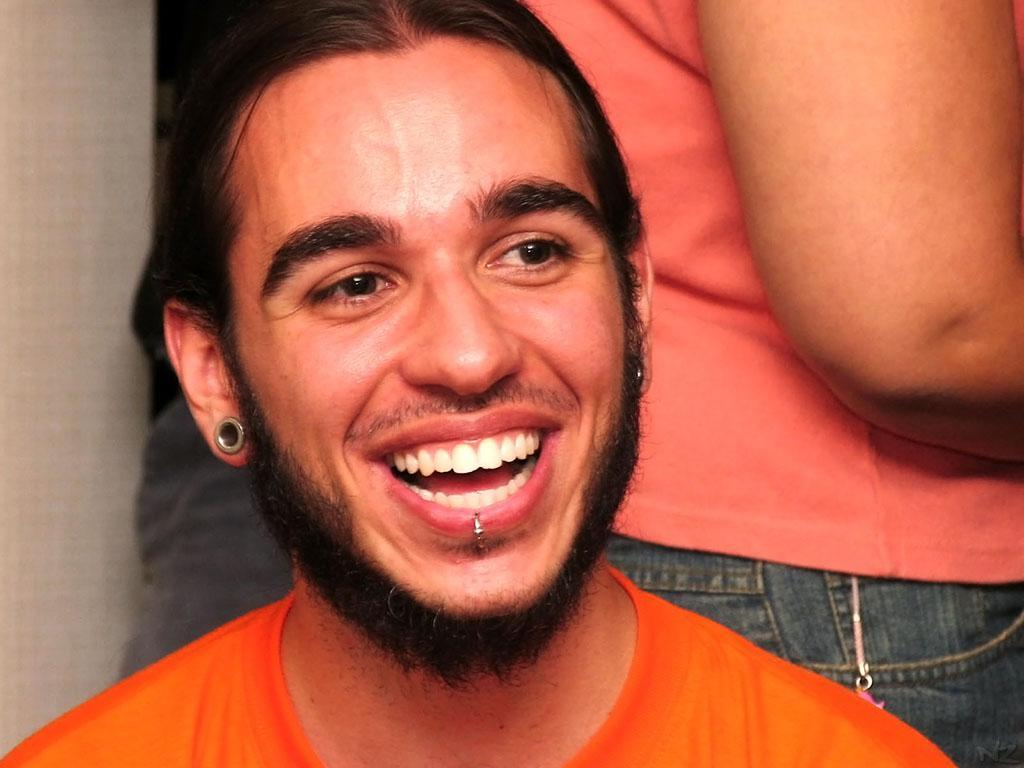What is the appearance of the man in the image? There is a bearded man in the image. What is the man wearing? The man is wearing an orange t-shirt. What is the man's facial expression? The man is smiling. Are there any other people in the image? Yes, there are two other persons standing behind the bearded man. How much money does the bearded man have in his pocket in the image? There is no information about the man's pocket or any money in the image. Are there any snakes visible in the image? There are no snakes present in the image. 